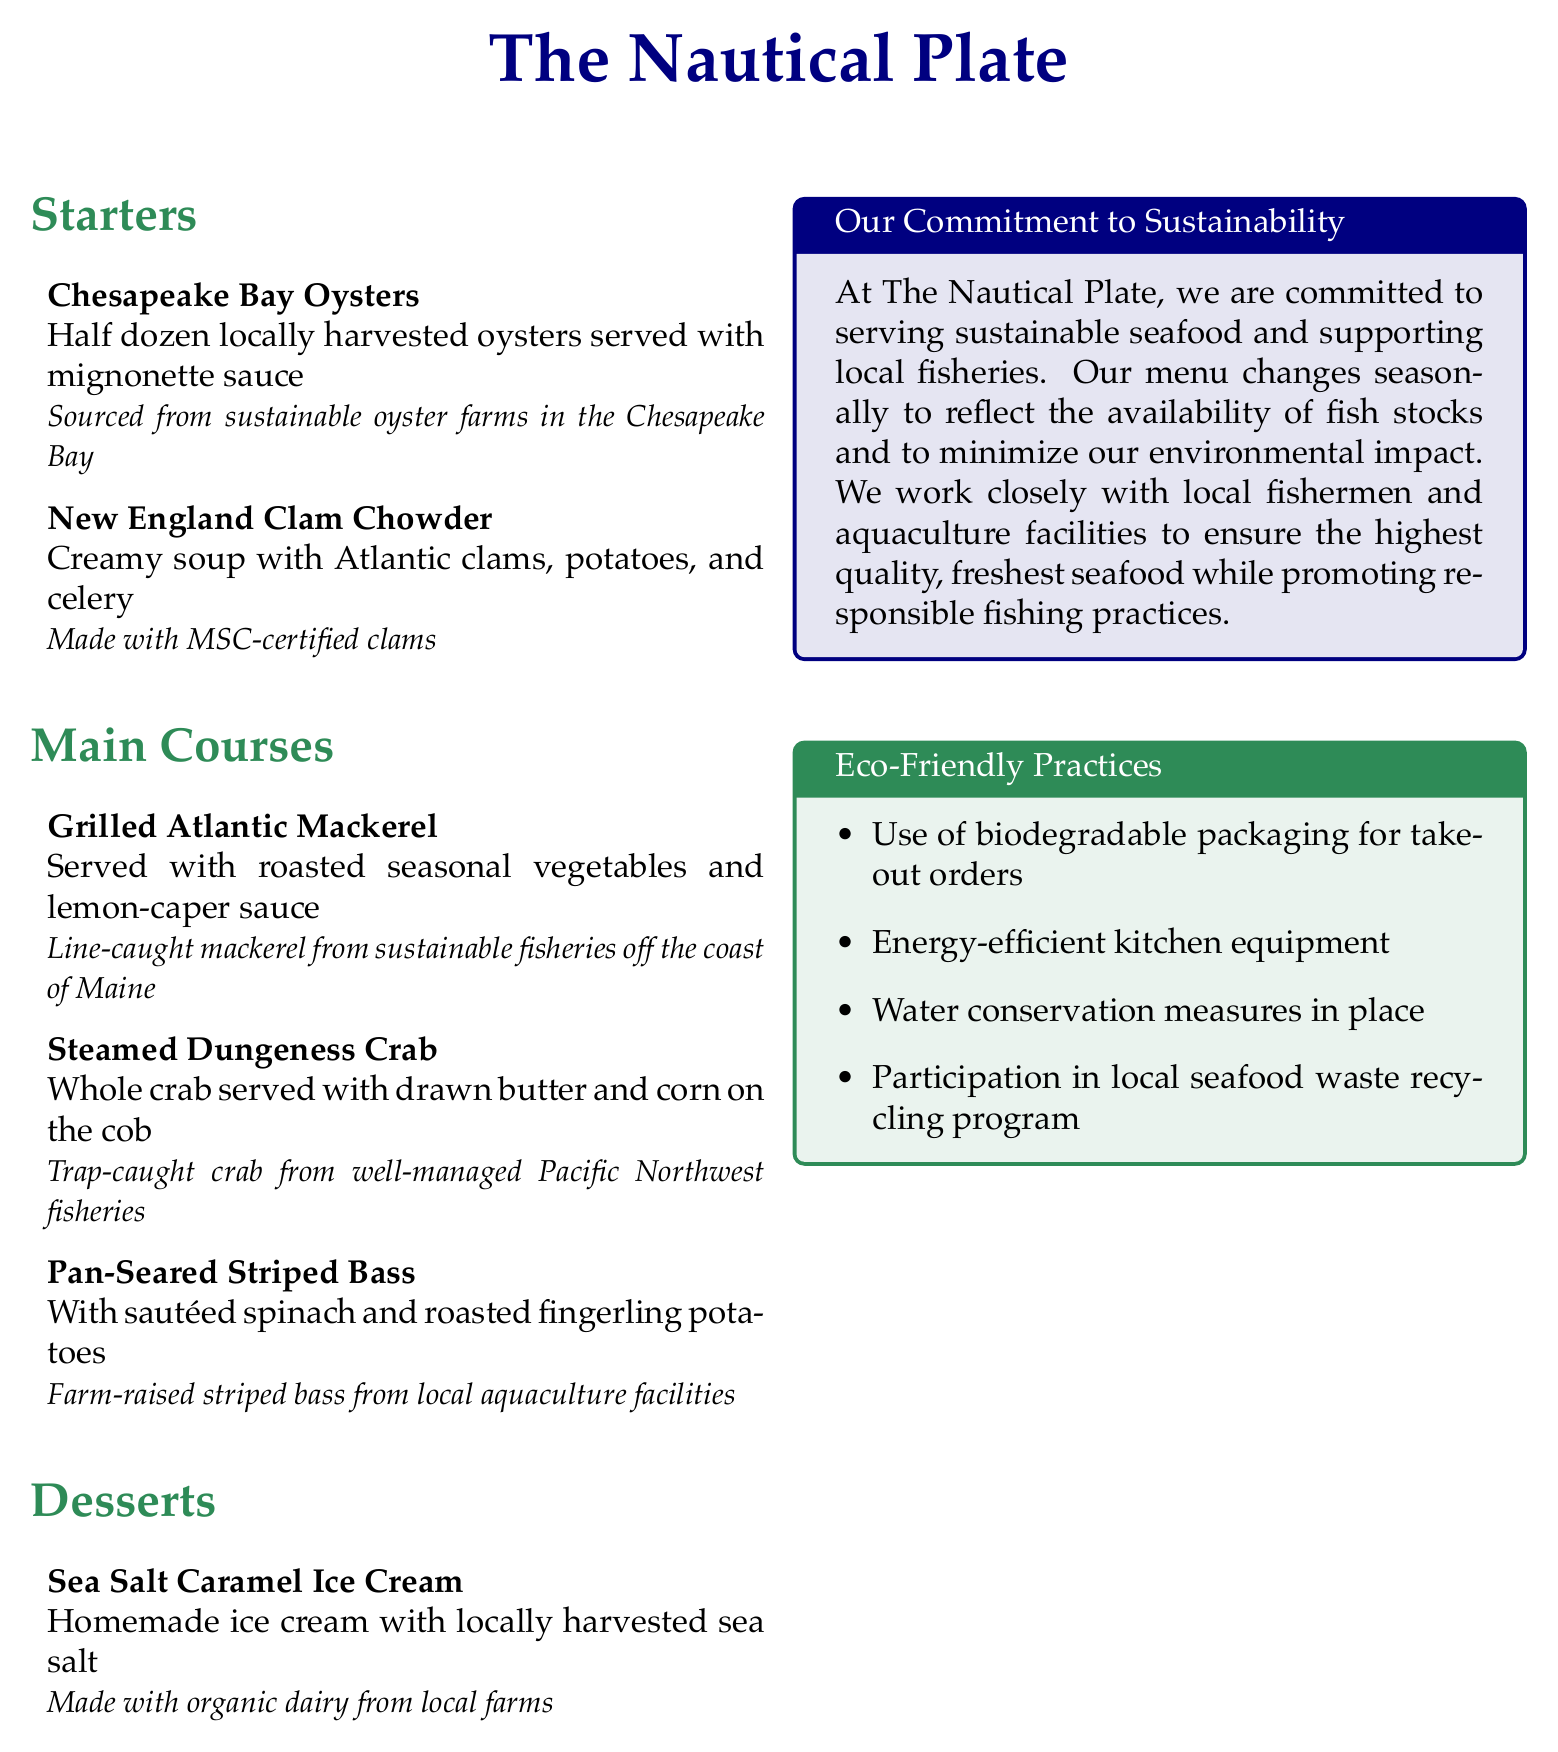what are the starters listed on the menu? The starters section lists the Chesapeake Bay Oysters and New England Clam Chowder.
Answer: Chesapeake Bay Oysters, New England Clam Chowder what type of oysters are served? The menu specifies that the oysters are locally harvested.
Answer: Locally harvested what type of clams are used in the chowder? The document mentions that the chowder is made with MSC-certified clams.
Answer: MSC-certified where is the grilled Atlantic mackerel sourced from? The menu states the mackerel is line-caught from sustainable fisheries off the coast of Maine.
Answer: Off the coast of Maine which dessert uses locally harvested sea salt? The dessert that uses locally harvested sea salt is the Sea Salt Caramel Ice Cream.
Answer: Sea Salt Caramel Ice Cream how does The Nautical Plate support sustainability? The document outlines that they work closely with local fishermen and aquaculture facilities.
Answer: Local fishermen and aquaculture facilities what type of crab is served in the main courses? The menu indicates that the crab served is Dungeness Crab.
Answer: Dungeness Crab how is the seafood prepared in an eco-friendly way? The document mentions participation in a local seafood waste recycling program.
Answer: Seafood waste recycling program how often does the menu change? The commitment to sustainability section states that the menu changes seasonally.
Answer: Seasonally 